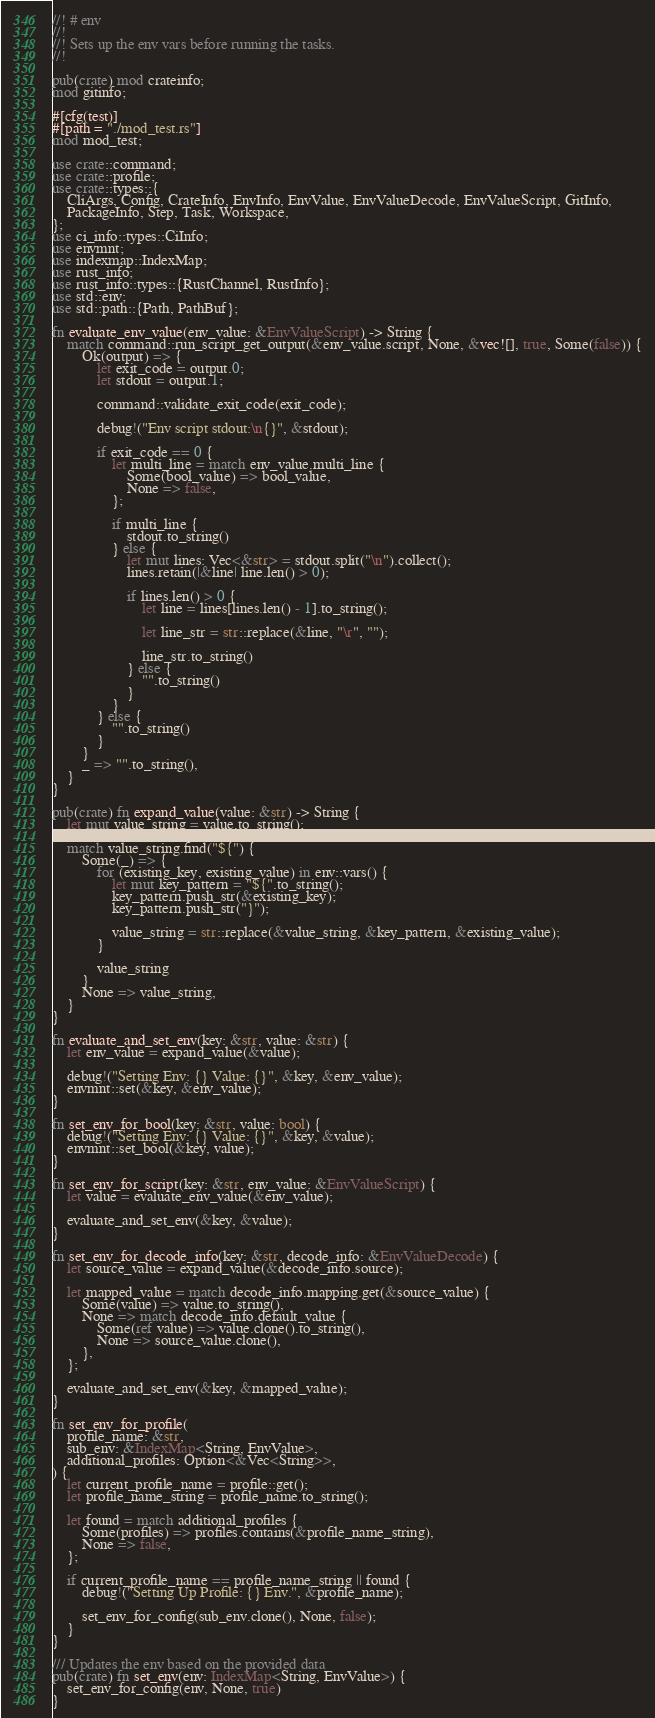<code> <loc_0><loc_0><loc_500><loc_500><_Rust_>//! # env
//!
//! Sets up the env vars before running the tasks.
//!

pub(crate) mod crateinfo;
mod gitinfo;

#[cfg(test)]
#[path = "./mod_test.rs"]
mod mod_test;

use crate::command;
use crate::profile;
use crate::types::{
    CliArgs, Config, CrateInfo, EnvInfo, EnvValue, EnvValueDecode, EnvValueScript, GitInfo,
    PackageInfo, Step, Task, Workspace,
};
use ci_info::types::CiInfo;
use envmnt;
use indexmap::IndexMap;
use rust_info;
use rust_info::types::{RustChannel, RustInfo};
use std::env;
use std::path::{Path, PathBuf};

fn evaluate_env_value(env_value: &EnvValueScript) -> String {
    match command::run_script_get_output(&env_value.script, None, &vec![], true, Some(false)) {
        Ok(output) => {
            let exit_code = output.0;
            let stdout = output.1;

            command::validate_exit_code(exit_code);

            debug!("Env script stdout:\n{}", &stdout);

            if exit_code == 0 {
                let multi_line = match env_value.multi_line {
                    Some(bool_value) => bool_value,
                    None => false,
                };

                if multi_line {
                    stdout.to_string()
                } else {
                    let mut lines: Vec<&str> = stdout.split("\n").collect();
                    lines.retain(|&line| line.len() > 0);

                    if lines.len() > 0 {
                        let line = lines[lines.len() - 1].to_string();

                        let line_str = str::replace(&line, "\r", "");

                        line_str.to_string()
                    } else {
                        "".to_string()
                    }
                }
            } else {
                "".to_string()
            }
        }
        _ => "".to_string(),
    }
}

pub(crate) fn expand_value(value: &str) -> String {
    let mut value_string = value.to_string();

    match value_string.find("${") {
        Some(_) => {
            for (existing_key, existing_value) in env::vars() {
                let mut key_pattern = "${".to_string();
                key_pattern.push_str(&existing_key);
                key_pattern.push_str("}");

                value_string = str::replace(&value_string, &key_pattern, &existing_value);
            }

            value_string
        }
        None => value_string,
    }
}

fn evaluate_and_set_env(key: &str, value: &str) {
    let env_value = expand_value(&value);

    debug!("Setting Env: {} Value: {}", &key, &env_value);
    envmnt::set(&key, &env_value);
}

fn set_env_for_bool(key: &str, value: bool) {
    debug!("Setting Env: {} Value: {}", &key, &value);
    envmnt::set_bool(&key, value);
}

fn set_env_for_script(key: &str, env_value: &EnvValueScript) {
    let value = evaluate_env_value(&env_value);

    evaluate_and_set_env(&key, &value);
}

fn set_env_for_decode_info(key: &str, decode_info: &EnvValueDecode) {
    let source_value = expand_value(&decode_info.source);

    let mapped_value = match decode_info.mapping.get(&source_value) {
        Some(value) => value.to_string(),
        None => match decode_info.default_value {
            Some(ref value) => value.clone().to_string(),
            None => source_value.clone(),
        },
    };

    evaluate_and_set_env(&key, &mapped_value);
}

fn set_env_for_profile(
    profile_name: &str,
    sub_env: &IndexMap<String, EnvValue>,
    additional_profiles: Option<&Vec<String>>,
) {
    let current_profile_name = profile::get();
    let profile_name_string = profile_name.to_string();

    let found = match additional_profiles {
        Some(profiles) => profiles.contains(&profile_name_string),
        None => false,
    };

    if current_profile_name == profile_name_string || found {
        debug!("Setting Up Profile: {} Env.", &profile_name);

        set_env_for_config(sub_env.clone(), None, false);
    }
}

/// Updates the env based on the provided data
pub(crate) fn set_env(env: IndexMap<String, EnvValue>) {
    set_env_for_config(env, None, true)
}
</code> 